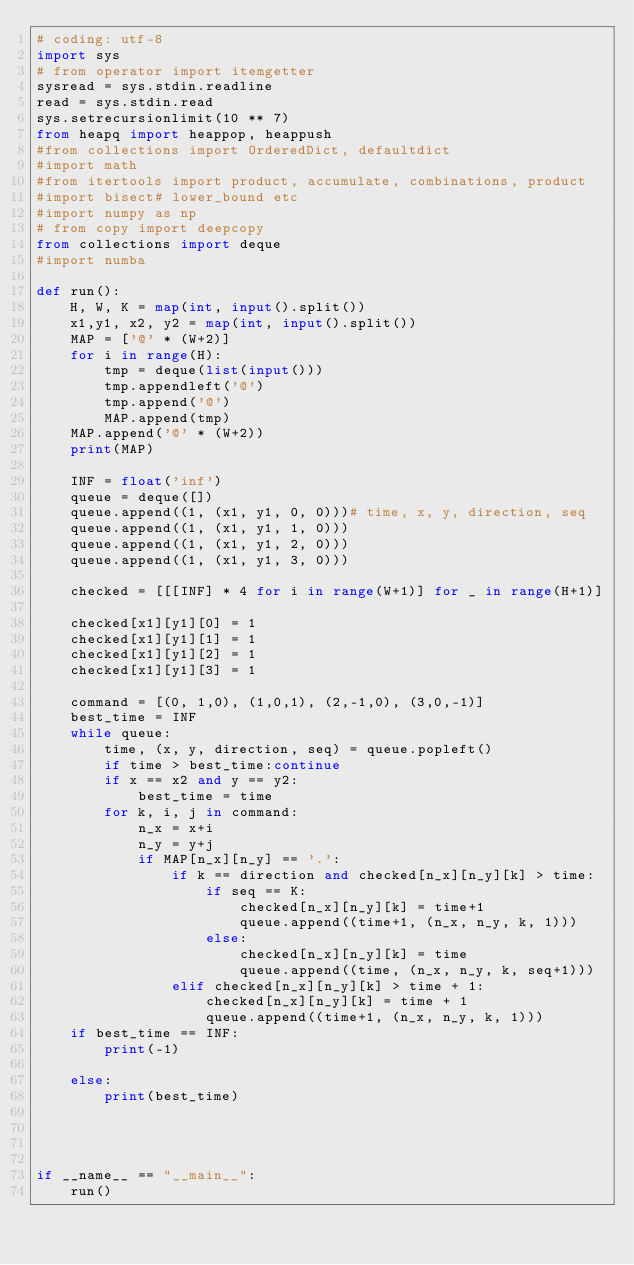Convert code to text. <code><loc_0><loc_0><loc_500><loc_500><_Python_># coding: utf-8
import sys
# from operator import itemgetter
sysread = sys.stdin.readline
read = sys.stdin.read
sys.setrecursionlimit(10 ** 7)
from heapq import heappop, heappush
#from collections import OrderedDict, defaultdict
#import math
#from itertools import product, accumulate, combinations, product
#import bisect# lower_bound etc
#import numpy as np
# from copy import deepcopy
from collections import deque
#import numba

def run():
    H, W, K = map(int, input().split())
    x1,y1, x2, y2 = map(int, input().split())
    MAP = ['@' * (W+2)]
    for i in range(H):
        tmp = deque(list(input()))
        tmp.appendleft('@')
        tmp.append('@')
        MAP.append(tmp)
    MAP.append('@' * (W+2))
    print(MAP)

    INF = float('inf')
    queue = deque([])
    queue.append((1, (x1, y1, 0, 0)))# time, x, y, direction, seq
    queue.append((1, (x1, y1, 1, 0)))
    queue.append((1, (x1, y1, 2, 0)))
    queue.append((1, (x1, y1, 3, 0)))

    checked = [[[INF] * 4 for i in range(W+1)] for _ in range(H+1)]

    checked[x1][y1][0] = 1
    checked[x1][y1][1] = 1
    checked[x1][y1][2] = 1
    checked[x1][y1][3] = 1

    command = [(0, 1,0), (1,0,1), (2,-1,0), (3,0,-1)]
    best_time = INF
    while queue:
        time, (x, y, direction, seq) = queue.popleft()
        if time > best_time:continue
        if x == x2 and y == y2:
            best_time = time
        for k, i, j in command:
            n_x = x+i
            n_y = y+j
            if MAP[n_x][n_y] == '.':
                if k == direction and checked[n_x][n_y][k] > time:
                    if seq == K:
                        checked[n_x][n_y][k] = time+1
                        queue.append((time+1, (n_x, n_y, k, 1)))
                    else:
                        checked[n_x][n_y][k] = time
                        queue.append((time, (n_x, n_y, k, seq+1)))
                elif checked[n_x][n_y][k] > time + 1:
                    checked[n_x][n_y][k] = time + 1
                    queue.append((time+1, (n_x, n_y, k, 1)))
    if best_time == INF:
        print(-1)

    else:
        print(best_time)




if __name__ == "__main__":
    run()</code> 